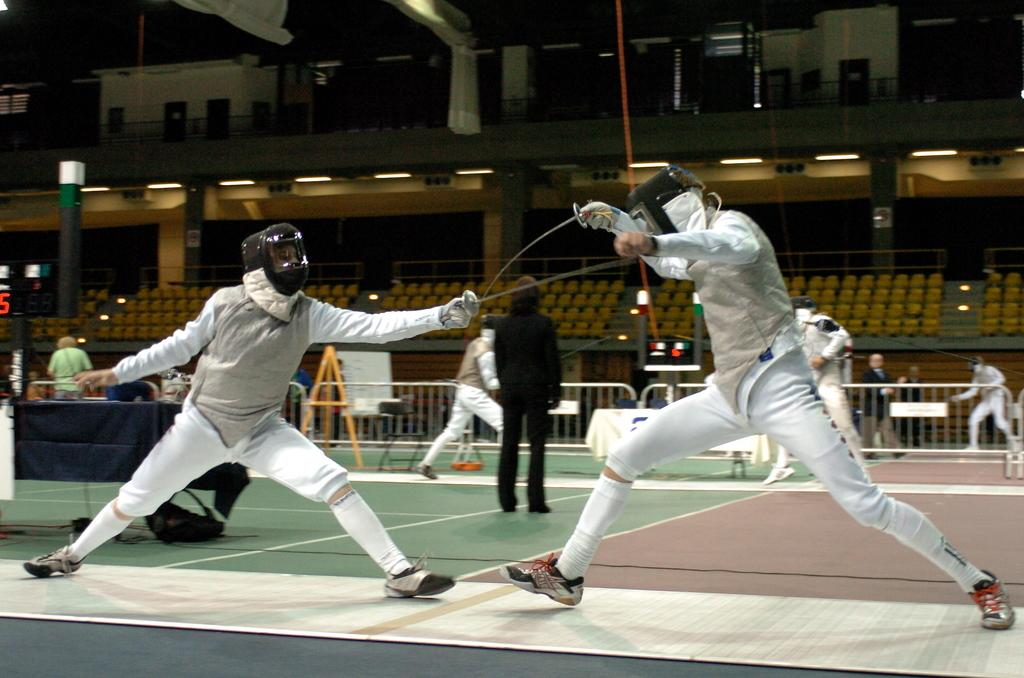What are the persons in the image doing? The persons in the image are fighting with swords. Where are the persons located in the image? The persons are standing on the floor in the image. What can be seen in the background of the image? In the background of the image, there are railing, pillars, seats, and electric lights. What type of pleasure can be seen in the image? There is no indication of pleasure in the image; the persons are fighting with swords. Can you tell me how many cannons are present in the image? There are no cannons present in the image. 